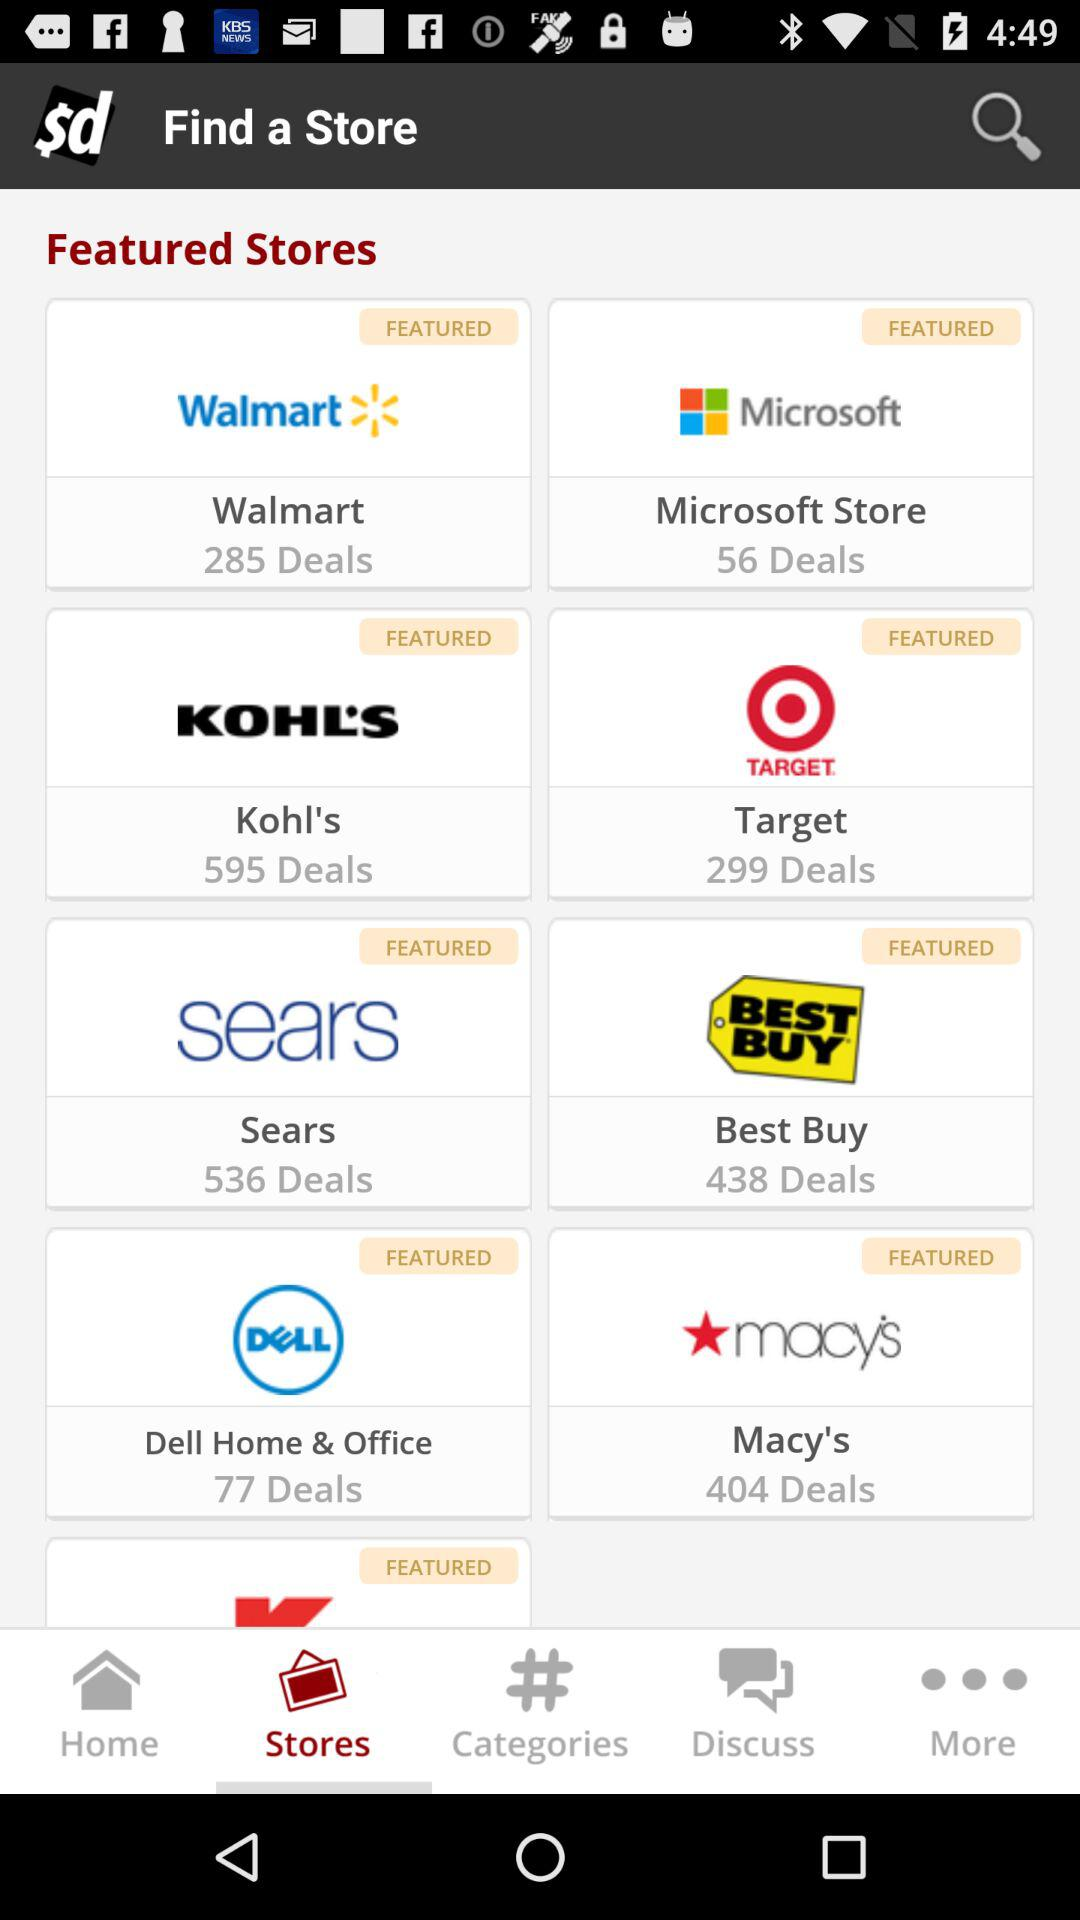How many deals are there in "Macy's"? There are 404 deals. 